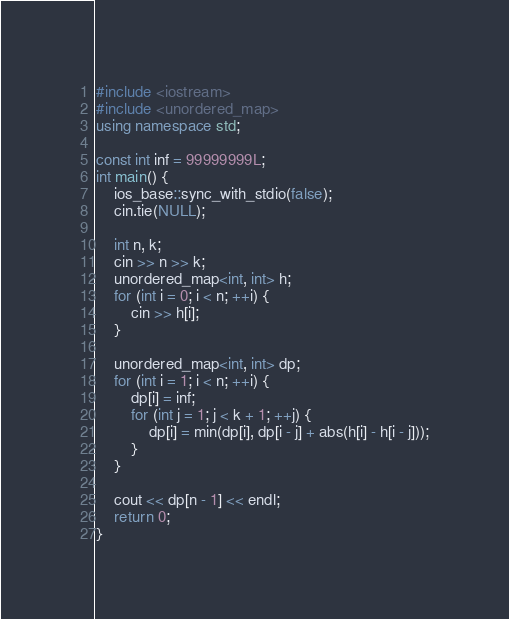Convert code to text. <code><loc_0><loc_0><loc_500><loc_500><_C++_>#include <iostream>
#include <unordered_map>
using namespace std;

const int inf = 99999999L;
int main() {
    ios_base::sync_with_stdio(false);
    cin.tie(NULL);

    int n, k;
    cin >> n >> k;
    unordered_map<int, int> h;
    for (int i = 0; i < n; ++i) {
        cin >> h[i];
    }

    unordered_map<int, int> dp;
    for (int i = 1; i < n; ++i) {
        dp[i] = inf;
        for (int j = 1; j < k + 1; ++j) {
            dp[i] = min(dp[i], dp[i - j] + abs(h[i] - h[i - j]));
        }
    }

    cout << dp[n - 1] << endl;
    return 0;
}
</code> 